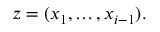<formula> <loc_0><loc_0><loc_500><loc_500>z = ( x _ { 1 } , \dots , x _ { i - 1 } ) .</formula> 